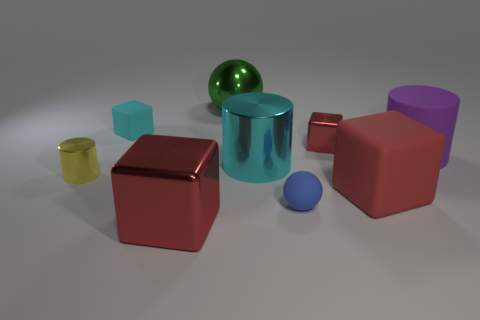Add 1 large red matte things. How many objects exist? 10 Subtract all red blocks. How many blocks are left? 1 Subtract all purple cylinders. How many cylinders are left? 2 Subtract 0 green cubes. How many objects are left? 9 Subtract all spheres. How many objects are left? 7 Subtract 2 cylinders. How many cylinders are left? 1 Subtract all blue cylinders. Subtract all blue blocks. How many cylinders are left? 3 Subtract all yellow cylinders. How many red cubes are left? 3 Subtract all tiny cyan cubes. Subtract all red metal blocks. How many objects are left? 6 Add 1 blue matte things. How many blue matte things are left? 2 